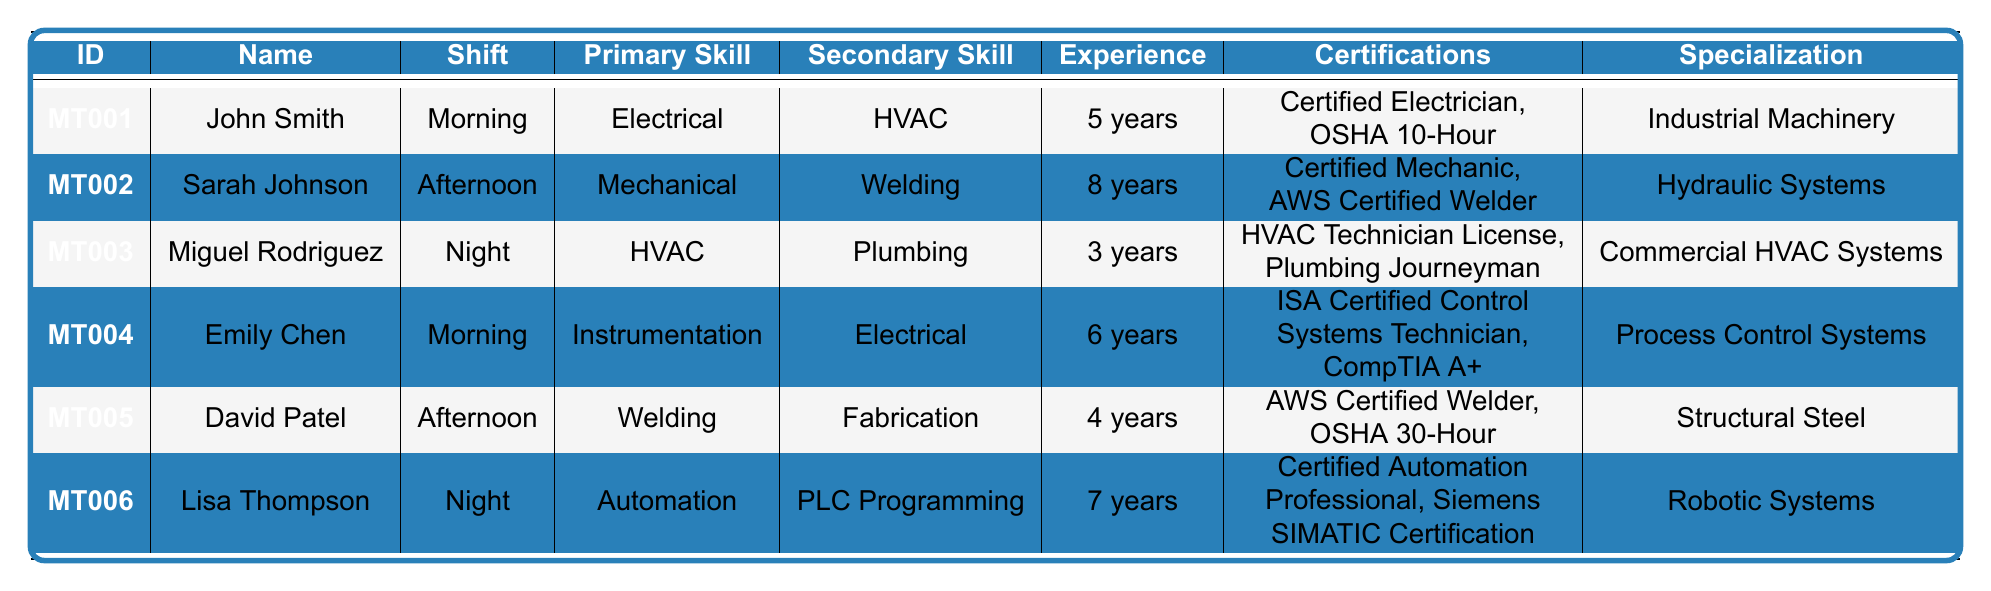What is the primary skill of Sarah Johnson? In the table, Sarah Johnson's primary skill is listed in the column labeled "Primary Skill". She is assigned to the value "Mechanical".
Answer: Mechanical How many years of experience does John Smith have? The "Experience" column indicates the number of years each technician has worked. For John Smith, it shows "5 years".
Answer: 5 years Which shift does Lisa Thompson work? The "Shift" column clearly indicates the shift timings for each technician. According to the table, Lisa Thompson works the "Night" shift.
Answer: Night Who has the most years of experience among the technicians? To find out who has the most experience, we need to compare the values in the "Experience" column. The highest value is "8 years" for Sarah Johnson.
Answer: Sarah Johnson Is Miguel Rodriguez certified as a plumber? Checking the "Certifications" column for Miguel Rodriguez, he has "Plumbing Journeyman" as one of his certifications, indicating he is certified.
Answer: Yes How many technicians have a primary skill in Electrical? Looking at the "Primary Skill" column, John Smith and Emily Chen have "Electrical" listed as their primary skill. Therefore, there are 2 technicians with this skill.
Answer: 2 What is the specialization of David Patel? The specialization for David Patel can be found in the "Specialization" column, where it states "Structural Steel".
Answer: Structural Steel What is the average years of experience among all technicians? To calculate the average, add the years of experience: 5 + 8 + 3 + 6 + 4 + 7 = 33 years. Then divide by the number of technicians (6) to get 33/6 = 5.5 years.
Answer: 5.5 years Which technician is specialized in "Commercial HVAC Systems"? The "Specialization" column lists "Commercial HVAC Systems" for Miguel Rodriguez.
Answer: Miguel Rodriguez Do any technicians work in both the Morning and Afternoon shifts? The shifts listed show that John Smith and Emily Chen work in the Morning, while Sarah Johnson and David Patel work in the Afternoon. No technician works both shifts.
Answer: No 